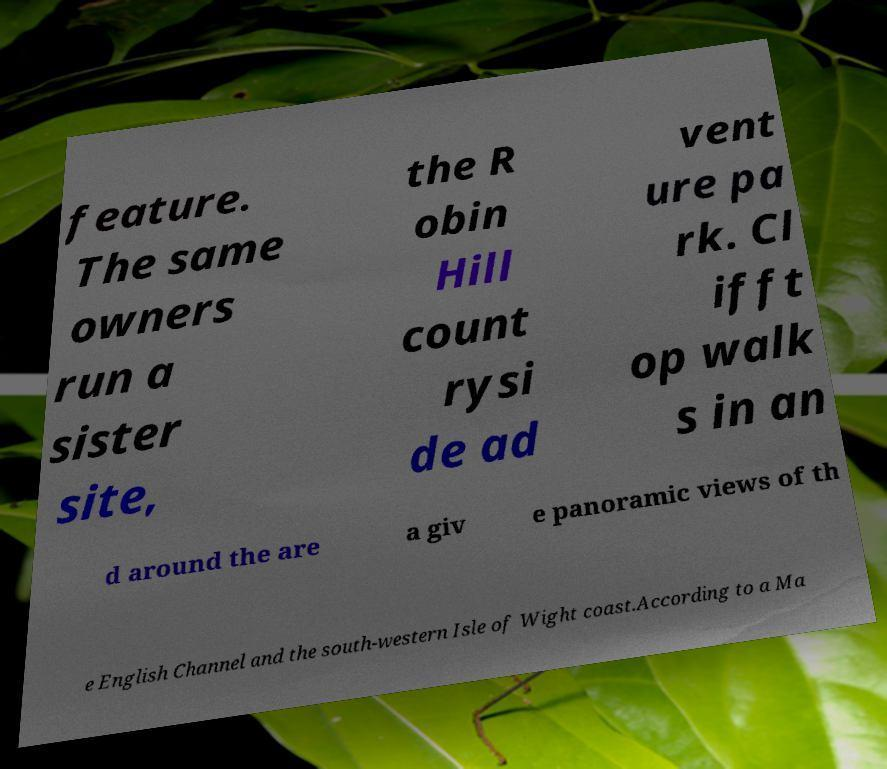I need the written content from this picture converted into text. Can you do that? feature. The same owners run a sister site, the R obin Hill count rysi de ad vent ure pa rk. Cl ifft op walk s in an d around the are a giv e panoramic views of th e English Channel and the south-western Isle of Wight coast.According to a Ma 